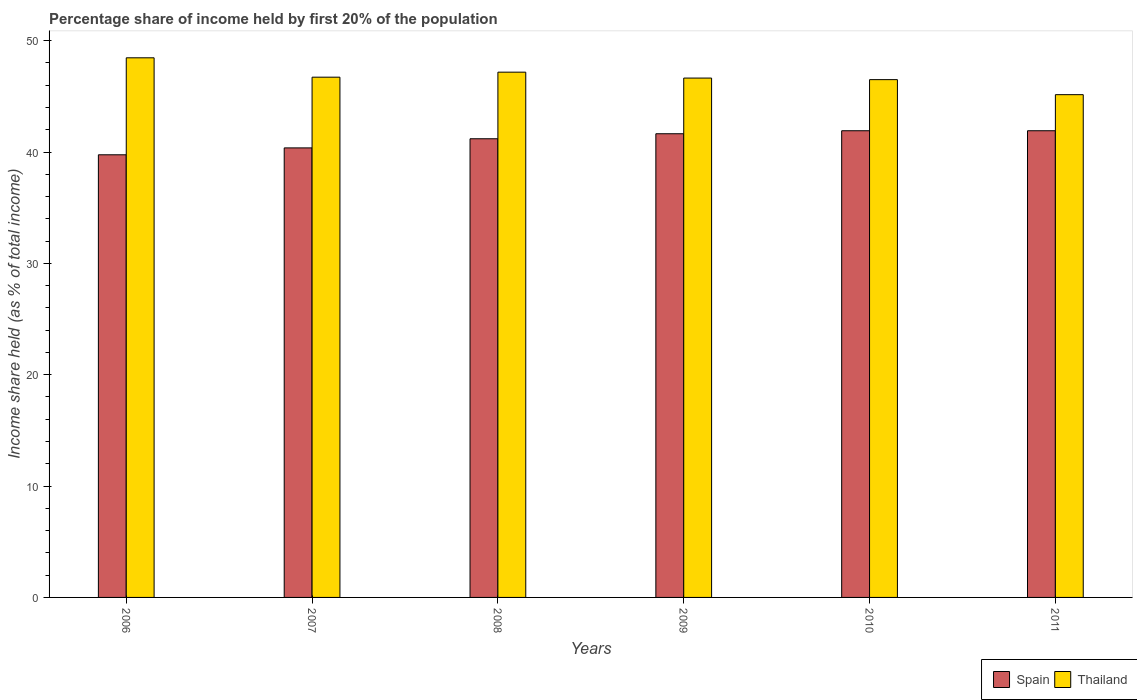Are the number of bars per tick equal to the number of legend labels?
Provide a short and direct response. Yes. What is the share of income held by first 20% of the population in Spain in 2009?
Ensure brevity in your answer.  41.64. Across all years, what is the maximum share of income held by first 20% of the population in Spain?
Give a very brief answer. 41.91. Across all years, what is the minimum share of income held by first 20% of the population in Spain?
Make the answer very short. 39.75. What is the total share of income held by first 20% of the population in Spain in the graph?
Keep it short and to the point. 246.77. What is the difference between the share of income held by first 20% of the population in Thailand in 2007 and that in 2011?
Make the answer very short. 1.57. What is the difference between the share of income held by first 20% of the population in Spain in 2011 and the share of income held by first 20% of the population in Thailand in 2008?
Give a very brief answer. -5.26. What is the average share of income held by first 20% of the population in Thailand per year?
Your response must be concise. 46.77. In the year 2007, what is the difference between the share of income held by first 20% of the population in Spain and share of income held by first 20% of the population in Thailand?
Offer a terse response. -6.35. In how many years, is the share of income held by first 20% of the population in Thailand greater than 40 %?
Offer a terse response. 6. What is the ratio of the share of income held by first 20% of the population in Spain in 2006 to that in 2008?
Make the answer very short. 0.97. Is the difference between the share of income held by first 20% of the population in Spain in 2006 and 2010 greater than the difference between the share of income held by first 20% of the population in Thailand in 2006 and 2010?
Give a very brief answer. No. What is the difference between the highest and the second highest share of income held by first 20% of the population in Thailand?
Your answer should be compact. 1.29. What is the difference between the highest and the lowest share of income held by first 20% of the population in Thailand?
Your answer should be very brief. 3.31. What does the 1st bar from the left in 2007 represents?
Your answer should be compact. Spain. What does the 2nd bar from the right in 2007 represents?
Provide a short and direct response. Spain. How many bars are there?
Your answer should be very brief. 12. Are the values on the major ticks of Y-axis written in scientific E-notation?
Offer a very short reply. No. Does the graph contain any zero values?
Provide a succinct answer. No. Does the graph contain grids?
Your answer should be very brief. No. Where does the legend appear in the graph?
Provide a short and direct response. Bottom right. What is the title of the graph?
Keep it short and to the point. Percentage share of income held by first 20% of the population. What is the label or title of the Y-axis?
Your answer should be compact. Income share held (as % of total income). What is the Income share held (as % of total income) in Spain in 2006?
Your answer should be very brief. 39.75. What is the Income share held (as % of total income) of Thailand in 2006?
Your answer should be compact. 48.46. What is the Income share held (as % of total income) of Spain in 2007?
Offer a terse response. 40.37. What is the Income share held (as % of total income) of Thailand in 2007?
Provide a short and direct response. 46.72. What is the Income share held (as % of total income) of Spain in 2008?
Your answer should be very brief. 41.19. What is the Income share held (as % of total income) of Thailand in 2008?
Make the answer very short. 47.17. What is the Income share held (as % of total income) in Spain in 2009?
Provide a short and direct response. 41.64. What is the Income share held (as % of total income) of Thailand in 2009?
Ensure brevity in your answer.  46.64. What is the Income share held (as % of total income) in Spain in 2010?
Provide a succinct answer. 41.91. What is the Income share held (as % of total income) of Thailand in 2010?
Provide a short and direct response. 46.5. What is the Income share held (as % of total income) in Spain in 2011?
Your answer should be very brief. 41.91. What is the Income share held (as % of total income) of Thailand in 2011?
Ensure brevity in your answer.  45.15. Across all years, what is the maximum Income share held (as % of total income) of Spain?
Your answer should be compact. 41.91. Across all years, what is the maximum Income share held (as % of total income) in Thailand?
Provide a succinct answer. 48.46. Across all years, what is the minimum Income share held (as % of total income) of Spain?
Provide a short and direct response. 39.75. Across all years, what is the minimum Income share held (as % of total income) of Thailand?
Keep it short and to the point. 45.15. What is the total Income share held (as % of total income) in Spain in the graph?
Keep it short and to the point. 246.77. What is the total Income share held (as % of total income) in Thailand in the graph?
Offer a very short reply. 280.64. What is the difference between the Income share held (as % of total income) of Spain in 2006 and that in 2007?
Provide a short and direct response. -0.62. What is the difference between the Income share held (as % of total income) in Thailand in 2006 and that in 2007?
Your answer should be compact. 1.74. What is the difference between the Income share held (as % of total income) in Spain in 2006 and that in 2008?
Keep it short and to the point. -1.44. What is the difference between the Income share held (as % of total income) in Thailand in 2006 and that in 2008?
Offer a terse response. 1.29. What is the difference between the Income share held (as % of total income) in Spain in 2006 and that in 2009?
Make the answer very short. -1.89. What is the difference between the Income share held (as % of total income) of Thailand in 2006 and that in 2009?
Give a very brief answer. 1.82. What is the difference between the Income share held (as % of total income) of Spain in 2006 and that in 2010?
Your response must be concise. -2.16. What is the difference between the Income share held (as % of total income) in Thailand in 2006 and that in 2010?
Keep it short and to the point. 1.96. What is the difference between the Income share held (as % of total income) of Spain in 2006 and that in 2011?
Your answer should be very brief. -2.16. What is the difference between the Income share held (as % of total income) in Thailand in 2006 and that in 2011?
Provide a succinct answer. 3.31. What is the difference between the Income share held (as % of total income) of Spain in 2007 and that in 2008?
Keep it short and to the point. -0.82. What is the difference between the Income share held (as % of total income) of Thailand in 2007 and that in 2008?
Provide a short and direct response. -0.45. What is the difference between the Income share held (as % of total income) in Spain in 2007 and that in 2009?
Offer a terse response. -1.27. What is the difference between the Income share held (as % of total income) of Thailand in 2007 and that in 2009?
Ensure brevity in your answer.  0.08. What is the difference between the Income share held (as % of total income) in Spain in 2007 and that in 2010?
Your response must be concise. -1.54. What is the difference between the Income share held (as % of total income) of Thailand in 2007 and that in 2010?
Give a very brief answer. 0.22. What is the difference between the Income share held (as % of total income) in Spain in 2007 and that in 2011?
Offer a very short reply. -1.54. What is the difference between the Income share held (as % of total income) in Thailand in 2007 and that in 2011?
Ensure brevity in your answer.  1.57. What is the difference between the Income share held (as % of total income) of Spain in 2008 and that in 2009?
Your answer should be very brief. -0.45. What is the difference between the Income share held (as % of total income) of Thailand in 2008 and that in 2009?
Ensure brevity in your answer.  0.53. What is the difference between the Income share held (as % of total income) of Spain in 2008 and that in 2010?
Make the answer very short. -0.72. What is the difference between the Income share held (as % of total income) of Thailand in 2008 and that in 2010?
Provide a short and direct response. 0.67. What is the difference between the Income share held (as % of total income) of Spain in 2008 and that in 2011?
Give a very brief answer. -0.72. What is the difference between the Income share held (as % of total income) of Thailand in 2008 and that in 2011?
Provide a short and direct response. 2.02. What is the difference between the Income share held (as % of total income) in Spain in 2009 and that in 2010?
Make the answer very short. -0.27. What is the difference between the Income share held (as % of total income) in Thailand in 2009 and that in 2010?
Give a very brief answer. 0.14. What is the difference between the Income share held (as % of total income) of Spain in 2009 and that in 2011?
Offer a terse response. -0.27. What is the difference between the Income share held (as % of total income) of Thailand in 2009 and that in 2011?
Give a very brief answer. 1.49. What is the difference between the Income share held (as % of total income) of Spain in 2010 and that in 2011?
Keep it short and to the point. 0. What is the difference between the Income share held (as % of total income) in Thailand in 2010 and that in 2011?
Ensure brevity in your answer.  1.35. What is the difference between the Income share held (as % of total income) in Spain in 2006 and the Income share held (as % of total income) in Thailand in 2007?
Provide a succinct answer. -6.97. What is the difference between the Income share held (as % of total income) in Spain in 2006 and the Income share held (as % of total income) in Thailand in 2008?
Your answer should be compact. -7.42. What is the difference between the Income share held (as % of total income) of Spain in 2006 and the Income share held (as % of total income) of Thailand in 2009?
Offer a very short reply. -6.89. What is the difference between the Income share held (as % of total income) of Spain in 2006 and the Income share held (as % of total income) of Thailand in 2010?
Provide a short and direct response. -6.75. What is the difference between the Income share held (as % of total income) in Spain in 2006 and the Income share held (as % of total income) in Thailand in 2011?
Keep it short and to the point. -5.4. What is the difference between the Income share held (as % of total income) in Spain in 2007 and the Income share held (as % of total income) in Thailand in 2009?
Make the answer very short. -6.27. What is the difference between the Income share held (as % of total income) in Spain in 2007 and the Income share held (as % of total income) in Thailand in 2010?
Offer a terse response. -6.13. What is the difference between the Income share held (as % of total income) in Spain in 2007 and the Income share held (as % of total income) in Thailand in 2011?
Ensure brevity in your answer.  -4.78. What is the difference between the Income share held (as % of total income) of Spain in 2008 and the Income share held (as % of total income) of Thailand in 2009?
Offer a very short reply. -5.45. What is the difference between the Income share held (as % of total income) in Spain in 2008 and the Income share held (as % of total income) in Thailand in 2010?
Your response must be concise. -5.31. What is the difference between the Income share held (as % of total income) of Spain in 2008 and the Income share held (as % of total income) of Thailand in 2011?
Offer a very short reply. -3.96. What is the difference between the Income share held (as % of total income) of Spain in 2009 and the Income share held (as % of total income) of Thailand in 2010?
Your answer should be very brief. -4.86. What is the difference between the Income share held (as % of total income) of Spain in 2009 and the Income share held (as % of total income) of Thailand in 2011?
Make the answer very short. -3.51. What is the difference between the Income share held (as % of total income) of Spain in 2010 and the Income share held (as % of total income) of Thailand in 2011?
Offer a terse response. -3.24. What is the average Income share held (as % of total income) of Spain per year?
Provide a short and direct response. 41.13. What is the average Income share held (as % of total income) of Thailand per year?
Provide a succinct answer. 46.77. In the year 2006, what is the difference between the Income share held (as % of total income) in Spain and Income share held (as % of total income) in Thailand?
Give a very brief answer. -8.71. In the year 2007, what is the difference between the Income share held (as % of total income) of Spain and Income share held (as % of total income) of Thailand?
Your response must be concise. -6.35. In the year 2008, what is the difference between the Income share held (as % of total income) of Spain and Income share held (as % of total income) of Thailand?
Offer a terse response. -5.98. In the year 2009, what is the difference between the Income share held (as % of total income) of Spain and Income share held (as % of total income) of Thailand?
Your answer should be compact. -5. In the year 2010, what is the difference between the Income share held (as % of total income) of Spain and Income share held (as % of total income) of Thailand?
Ensure brevity in your answer.  -4.59. In the year 2011, what is the difference between the Income share held (as % of total income) of Spain and Income share held (as % of total income) of Thailand?
Your response must be concise. -3.24. What is the ratio of the Income share held (as % of total income) in Spain in 2006 to that in 2007?
Your answer should be very brief. 0.98. What is the ratio of the Income share held (as % of total income) in Thailand in 2006 to that in 2007?
Provide a short and direct response. 1.04. What is the ratio of the Income share held (as % of total income) in Spain in 2006 to that in 2008?
Offer a terse response. 0.96. What is the ratio of the Income share held (as % of total income) of Thailand in 2006 to that in 2008?
Offer a very short reply. 1.03. What is the ratio of the Income share held (as % of total income) in Spain in 2006 to that in 2009?
Your response must be concise. 0.95. What is the ratio of the Income share held (as % of total income) in Thailand in 2006 to that in 2009?
Your answer should be compact. 1.04. What is the ratio of the Income share held (as % of total income) of Spain in 2006 to that in 2010?
Your answer should be compact. 0.95. What is the ratio of the Income share held (as % of total income) in Thailand in 2006 to that in 2010?
Offer a terse response. 1.04. What is the ratio of the Income share held (as % of total income) in Spain in 2006 to that in 2011?
Your answer should be compact. 0.95. What is the ratio of the Income share held (as % of total income) in Thailand in 2006 to that in 2011?
Offer a terse response. 1.07. What is the ratio of the Income share held (as % of total income) in Spain in 2007 to that in 2008?
Provide a short and direct response. 0.98. What is the ratio of the Income share held (as % of total income) in Thailand in 2007 to that in 2008?
Make the answer very short. 0.99. What is the ratio of the Income share held (as % of total income) of Spain in 2007 to that in 2009?
Your answer should be very brief. 0.97. What is the ratio of the Income share held (as % of total income) in Spain in 2007 to that in 2010?
Your response must be concise. 0.96. What is the ratio of the Income share held (as % of total income) in Spain in 2007 to that in 2011?
Your response must be concise. 0.96. What is the ratio of the Income share held (as % of total income) in Thailand in 2007 to that in 2011?
Offer a terse response. 1.03. What is the ratio of the Income share held (as % of total income) of Spain in 2008 to that in 2009?
Provide a succinct answer. 0.99. What is the ratio of the Income share held (as % of total income) of Thailand in 2008 to that in 2009?
Offer a terse response. 1.01. What is the ratio of the Income share held (as % of total income) in Spain in 2008 to that in 2010?
Provide a short and direct response. 0.98. What is the ratio of the Income share held (as % of total income) in Thailand in 2008 to that in 2010?
Ensure brevity in your answer.  1.01. What is the ratio of the Income share held (as % of total income) in Spain in 2008 to that in 2011?
Give a very brief answer. 0.98. What is the ratio of the Income share held (as % of total income) in Thailand in 2008 to that in 2011?
Your response must be concise. 1.04. What is the ratio of the Income share held (as % of total income) in Spain in 2009 to that in 2011?
Keep it short and to the point. 0.99. What is the ratio of the Income share held (as % of total income) in Thailand in 2009 to that in 2011?
Keep it short and to the point. 1.03. What is the ratio of the Income share held (as % of total income) of Thailand in 2010 to that in 2011?
Offer a very short reply. 1.03. What is the difference between the highest and the second highest Income share held (as % of total income) of Thailand?
Your answer should be compact. 1.29. What is the difference between the highest and the lowest Income share held (as % of total income) in Spain?
Ensure brevity in your answer.  2.16. What is the difference between the highest and the lowest Income share held (as % of total income) in Thailand?
Your answer should be very brief. 3.31. 